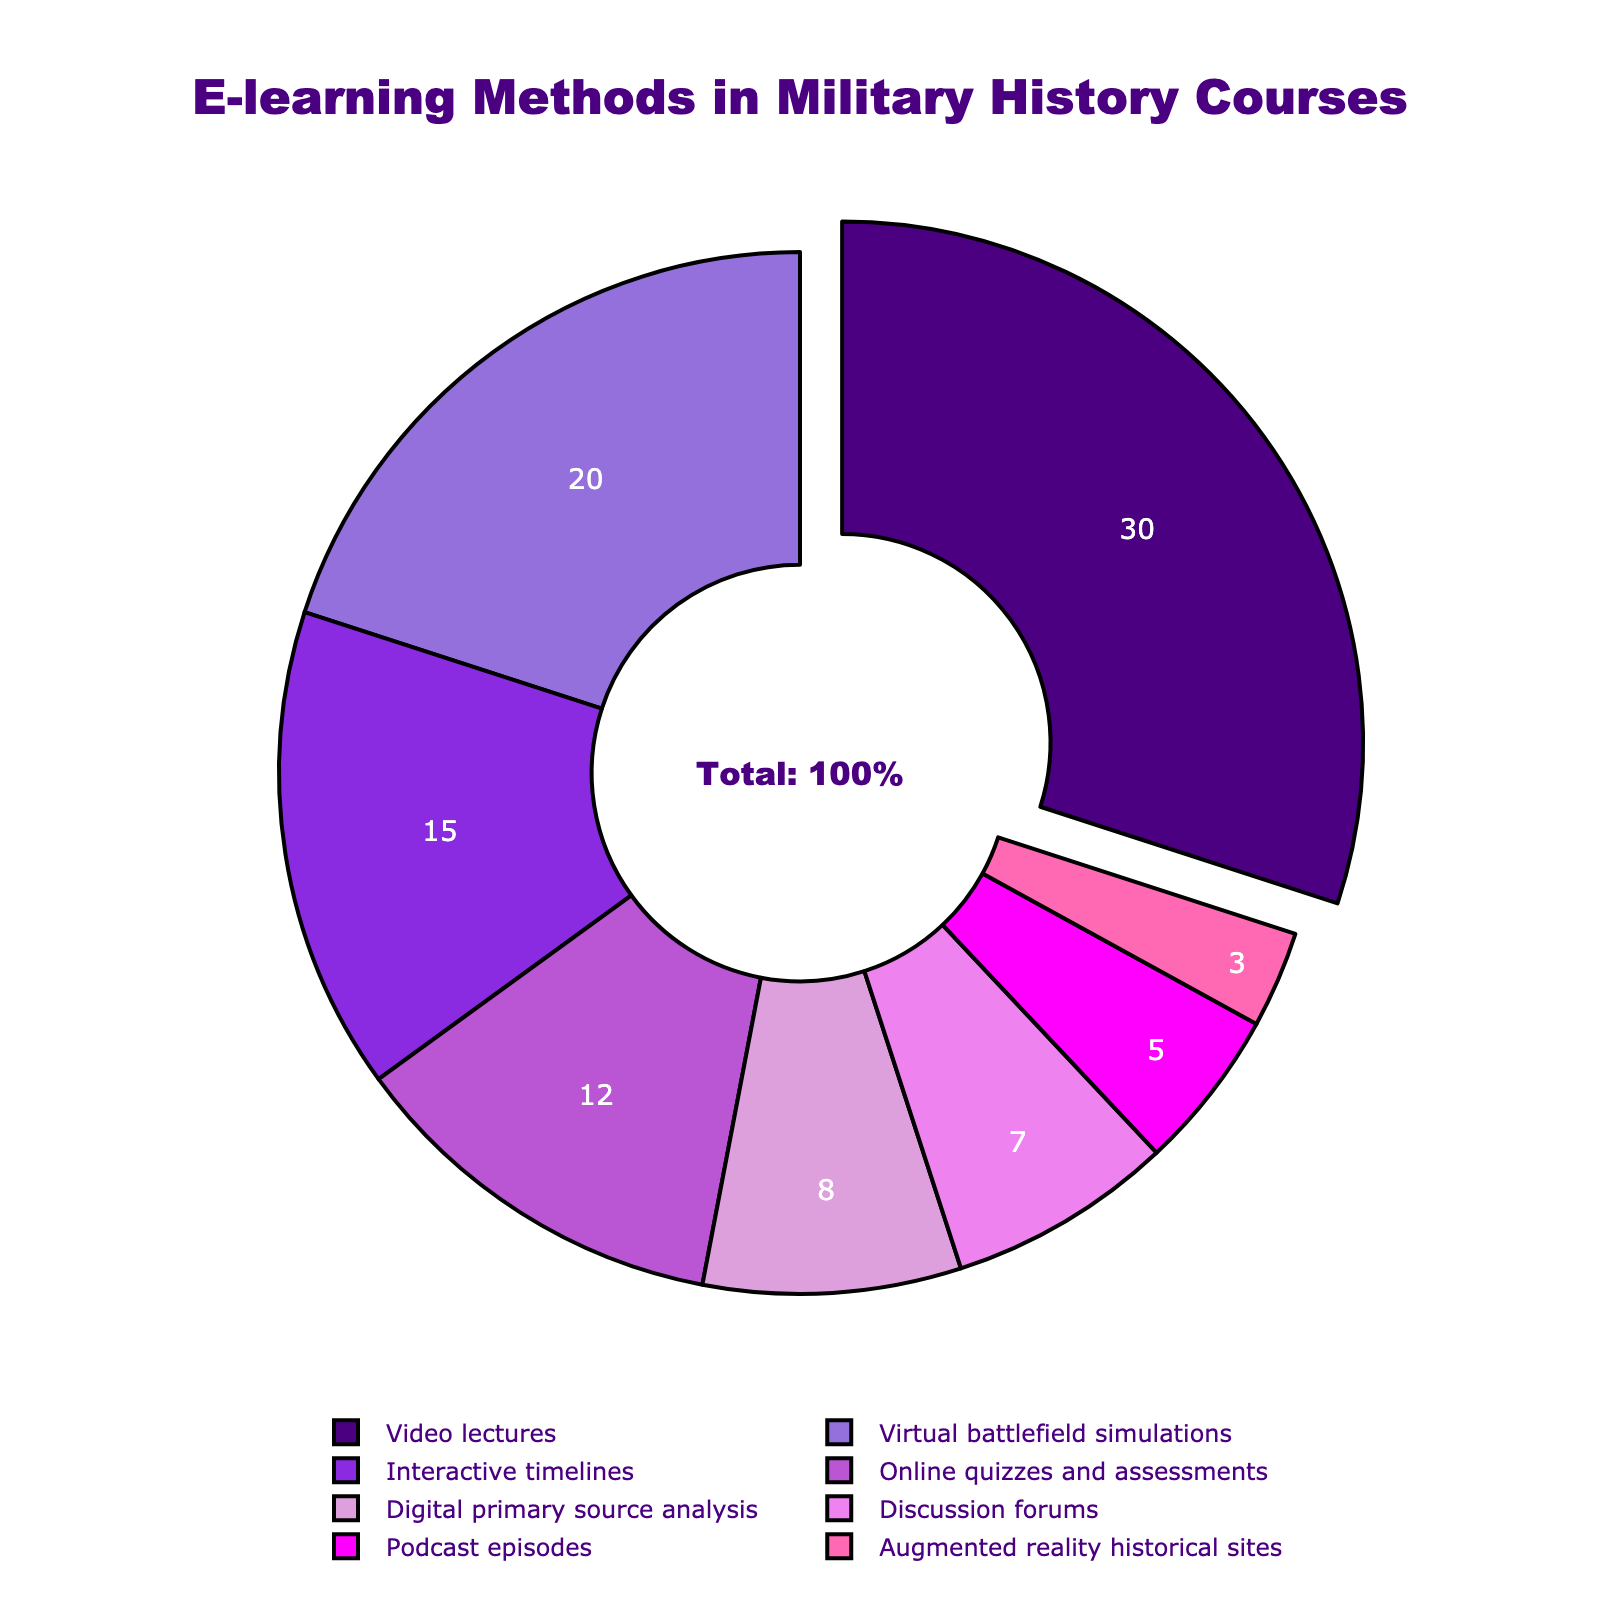Which e-learning method has the highest percentage? The figure shows several e-learning methods with their respective percentages. The method with the highest percentage is the one that has a segment pulled out from the pie chart.
Answer: Video lectures How many methods have a percentage less than 10%? To answer this, count the segments of the pie chart that are labeled with percentages less than 10%. The segments for Podcast episodes, Augmented reality historical sites, Discussion forums, and Digital primary source analysis meet this criterion.
Answer: 4 What is the combined percentage of Virtual battlefield simulations and Online quizzes and assessments? Identify the percentages for Virtual battlefield simulations and Online quizzes and assessments. Sum these two percentages: 20% for Virtual battlefield simulations and 12% for Online quizzes and assessments. 20 + 12 = 32
Answer: 32% Which method has the smallest share, and what is its percentage? Look for the smallest segment in the pie chart. The label associated with this smallest segment is Augmented reality historical sites, and its percentage is indicated as 3%.
Answer: Augmented reality historical sites, 3% Compare the percentages of Interactive timelines and Online quizzes and assessments. Which one is higher and by how much? Find the segments for Interactive timelines and Online quizzes and assessments. Interactive timelines have 15%, and Online quizzes and assessments have 12%. The difference between them is 15 - 12 = 3.
Answer: Interactive timelines, 3% What is the total percentage of methods that use simulations in some form? Identify the methods related to simulations: Virtual battlefield simulations (20%) and Augmented reality historical sites (3%). Sum these percentages: 20 + 3 = 23.
Answer: 23% Identify the methods represented by the purple color and their respective percentages. Look at the segments that are colored purple. There are two shades of purple used in the pie chart. Video lectures (30%) and Interactive timelines (15%) are in shades of purple.
Answer: Video lectures (30%), Interactive timelines (15%) If you wanted to focus equally on Digital primary source analysis and Podcast episodes, what combined percentage would you be allocating? Find the percentages for Digital primary source analysis and Podcast episodes: 8% and 5%. Sum these two percentages: 8 + 5 = 13.
Answer: 13% By how much does the percentage of Video lectures exceed that of Discussion forums? Locate the percentages for Video lectures and Discussion forums: 30% and 7%, respectively. Subtract the smaller percentage from the larger one: 30 - 7 = 23.
Answer: 23 Calculate the average percentage of the methods with less than 10% representation. Identify the methods with less than 10% representation: Digital primary source analysis (8%), Discussion forums (7%), Podcast episodes (5%), and Augmented reality historical sites (3%). Sum these percentages = 8 + 7 + 5 + 3 = 23, and then divide by the number of methods = 23 / 4 = 5.75.
Answer: 5.75% 